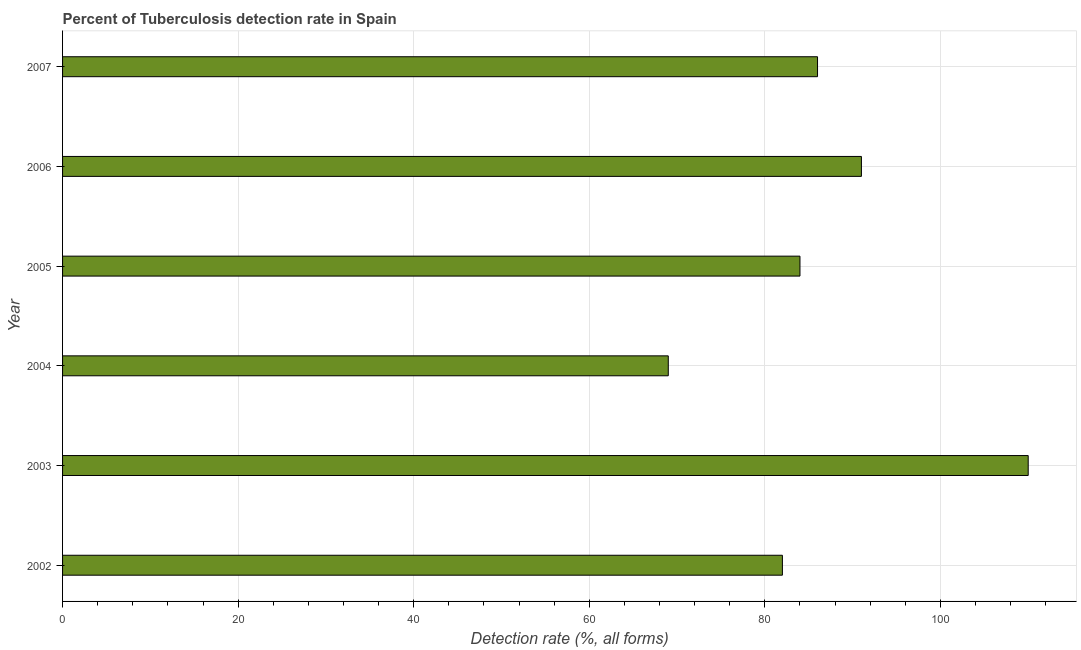What is the title of the graph?
Provide a succinct answer. Percent of Tuberculosis detection rate in Spain. What is the label or title of the X-axis?
Keep it short and to the point. Detection rate (%, all forms). Across all years, what is the maximum detection rate of tuberculosis?
Keep it short and to the point. 110. In which year was the detection rate of tuberculosis maximum?
Ensure brevity in your answer.  2003. What is the sum of the detection rate of tuberculosis?
Make the answer very short. 522. What is the difference between the detection rate of tuberculosis in 2002 and 2006?
Provide a succinct answer. -9. Do a majority of the years between 2002 and 2007 (inclusive) have detection rate of tuberculosis greater than 16 %?
Give a very brief answer. Yes. What is the ratio of the detection rate of tuberculosis in 2004 to that in 2007?
Make the answer very short. 0.8. Is the detection rate of tuberculosis in 2006 less than that in 2007?
Your response must be concise. No. Is the difference between the detection rate of tuberculosis in 2005 and 2007 greater than the difference between any two years?
Provide a short and direct response. No. What is the difference between the highest and the lowest detection rate of tuberculosis?
Make the answer very short. 41. How many bars are there?
Ensure brevity in your answer.  6. Are all the bars in the graph horizontal?
Offer a very short reply. Yes. What is the difference between two consecutive major ticks on the X-axis?
Give a very brief answer. 20. What is the Detection rate (%, all forms) in 2003?
Provide a short and direct response. 110. What is the Detection rate (%, all forms) of 2004?
Provide a short and direct response. 69. What is the Detection rate (%, all forms) of 2006?
Ensure brevity in your answer.  91. What is the difference between the Detection rate (%, all forms) in 2002 and 2004?
Provide a short and direct response. 13. What is the difference between the Detection rate (%, all forms) in 2002 and 2007?
Provide a succinct answer. -4. What is the difference between the Detection rate (%, all forms) in 2003 and 2004?
Your answer should be very brief. 41. What is the difference between the Detection rate (%, all forms) in 2004 and 2005?
Your answer should be compact. -15. What is the difference between the Detection rate (%, all forms) in 2004 and 2007?
Your response must be concise. -17. What is the ratio of the Detection rate (%, all forms) in 2002 to that in 2003?
Offer a terse response. 0.74. What is the ratio of the Detection rate (%, all forms) in 2002 to that in 2004?
Your response must be concise. 1.19. What is the ratio of the Detection rate (%, all forms) in 2002 to that in 2006?
Make the answer very short. 0.9. What is the ratio of the Detection rate (%, all forms) in 2002 to that in 2007?
Provide a succinct answer. 0.95. What is the ratio of the Detection rate (%, all forms) in 2003 to that in 2004?
Ensure brevity in your answer.  1.59. What is the ratio of the Detection rate (%, all forms) in 2003 to that in 2005?
Make the answer very short. 1.31. What is the ratio of the Detection rate (%, all forms) in 2003 to that in 2006?
Offer a terse response. 1.21. What is the ratio of the Detection rate (%, all forms) in 2003 to that in 2007?
Offer a terse response. 1.28. What is the ratio of the Detection rate (%, all forms) in 2004 to that in 2005?
Provide a short and direct response. 0.82. What is the ratio of the Detection rate (%, all forms) in 2004 to that in 2006?
Your response must be concise. 0.76. What is the ratio of the Detection rate (%, all forms) in 2004 to that in 2007?
Give a very brief answer. 0.8. What is the ratio of the Detection rate (%, all forms) in 2005 to that in 2006?
Provide a short and direct response. 0.92. What is the ratio of the Detection rate (%, all forms) in 2005 to that in 2007?
Keep it short and to the point. 0.98. What is the ratio of the Detection rate (%, all forms) in 2006 to that in 2007?
Give a very brief answer. 1.06. 